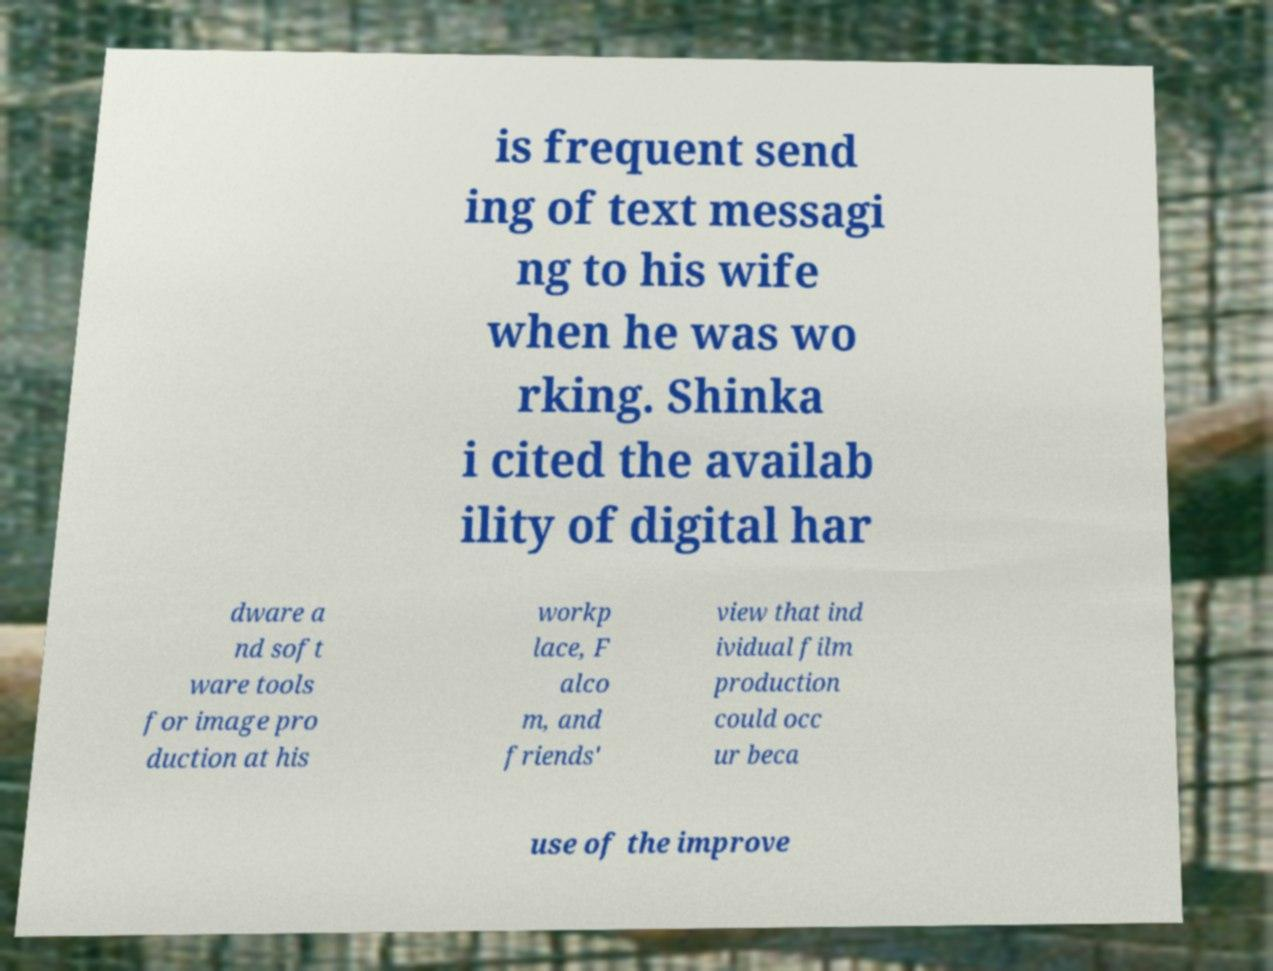For documentation purposes, I need the text within this image transcribed. Could you provide that? is frequent send ing of text messagi ng to his wife when he was wo rking. Shinka i cited the availab ility of digital har dware a nd soft ware tools for image pro duction at his workp lace, F alco m, and friends' view that ind ividual film production could occ ur beca use of the improve 